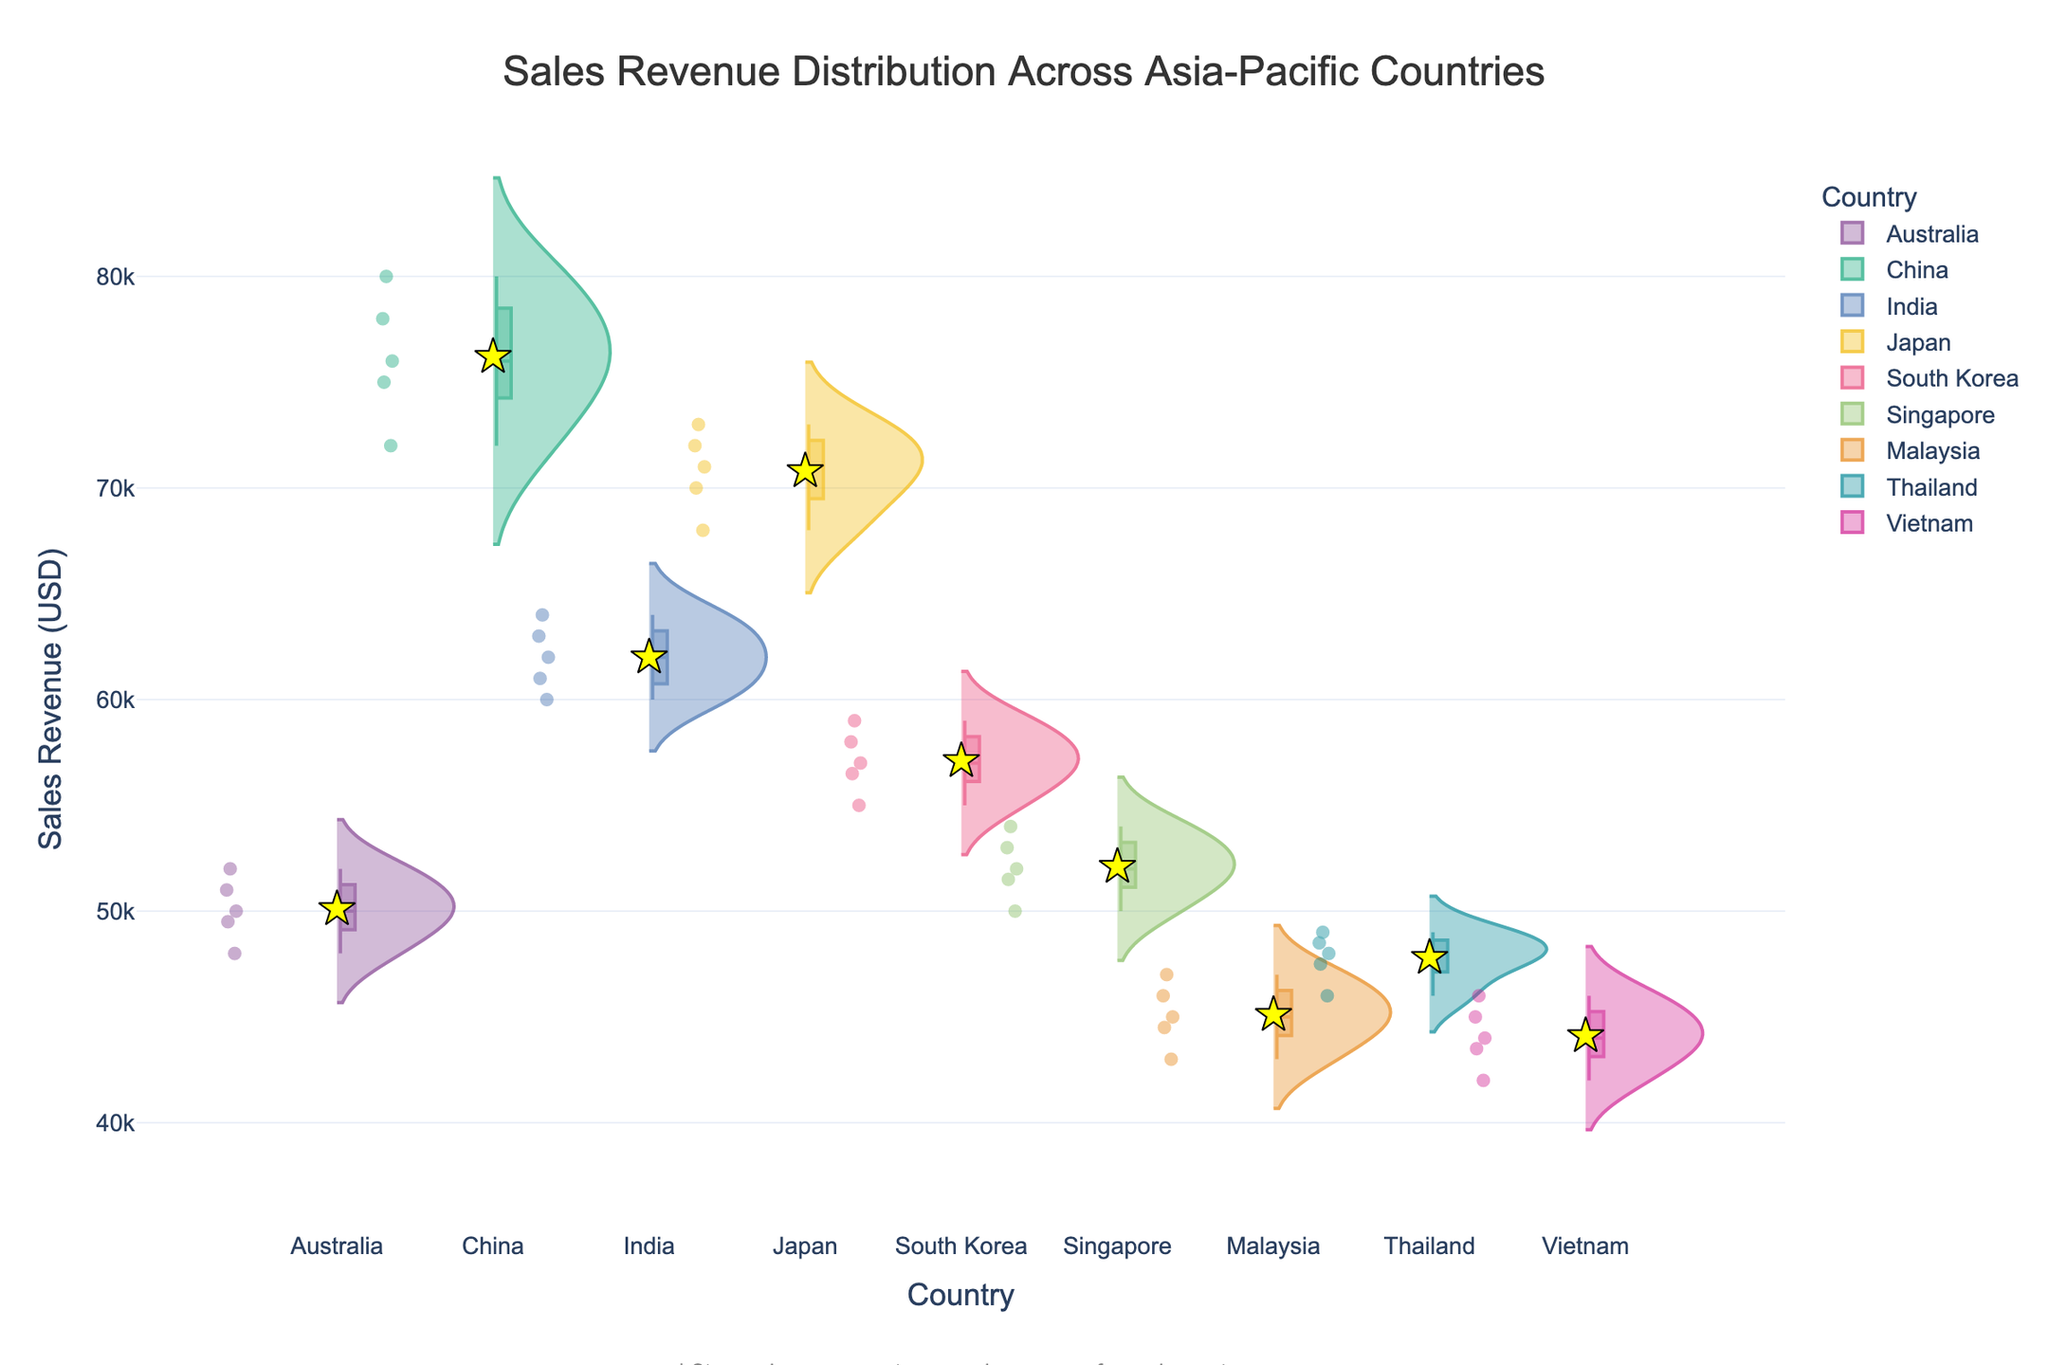What is the title of the figure? The title is prominently displayed at the top of the figure. It reads "Sales Revenue Distribution Across Asia-Pacific Countries".
Answer: Sales Revenue Distribution Across Asia-Pacific Countries What does the y-axis represent? The y-axis label is "Sales Revenue (USD)", indicating it represents sales revenue values in US dollars.
Answer: Sales Revenue (USD) Which country has the highest mean sales revenue? The mean sales revenue is represented by star markers. By examining the position of these markers on the y-axis, we see that China has the highest mean, as its star marker is the highest.
Answer: China What is the approximate range of sales revenue for Malaysia? By looking at the spread of the violin plot for Malaysia, the sales revenue ranges from approximately 43,000 to 47,000 USD.
Answer: 43,000 to 47,000 USD How does the sales revenue distribution of Singapore compare to that of South Korea? By comparing the shapes and spreads of the violin plots for Singapore and South Korea, it's evident that Singapore's sales distribution is slightly higher and more varied than South Korea's, which is more compact and centered around a lower range.
Answer: Singapore's distribution is slightly higher and more varied Which country has the narrowest distribution of sales revenue? Examining the width and spread of the violin plots, Japan has the narrowest distribution of sales revenue, meaning its sales values are more clustered around the mean.
Answer: Japan Are there any countries where the sales revenue values are bi-modal or have multiple peaks? By observing the shape of the violin plots, none of the countries show a bi-modal distribution; all appear to have single, central peaks.
Answer: None What is the lowest recorded sales revenue in the dataset? The lowest points on the violin plots indicate the minimum values. The minimum value is approximately 42,000 USD, which is seen in Vietnam and Malaysia.
Answer: 42,000 USD Which country's sales revenue distribution overlaps the most with other countries? By examining the degree of overlap of the violin plots, Australia, with its moderate values, seems to have the most overlap with other countries.
Answer: Australia What role do the star markers play in the figure? The star markers represent the mean sales revenue for each country, helping to quickly identify and compare the central tendency of sales values across different countries.
Answer: Mean sales revenue for each country 